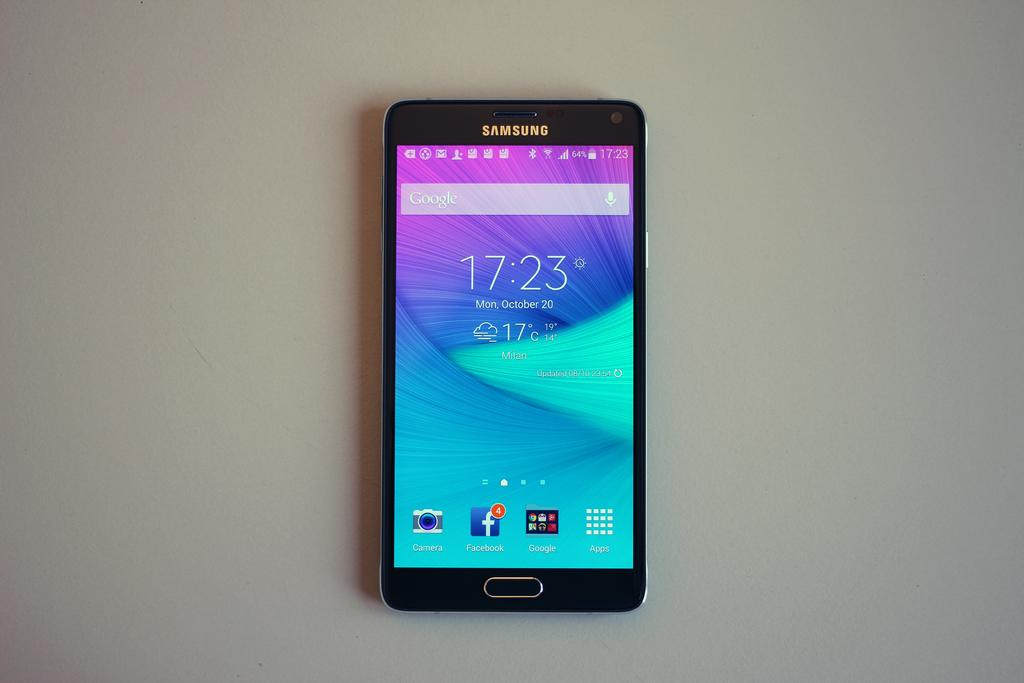What is the main object in the image? There is a mobile in the image. Where is the mobile located? The mobile is on a platform. What can be seen on the mobile's screen? There are icons visible on the mobile's screen. What color is the crayon being used by the friends in the image? There are no friends or crayons present in the image. 